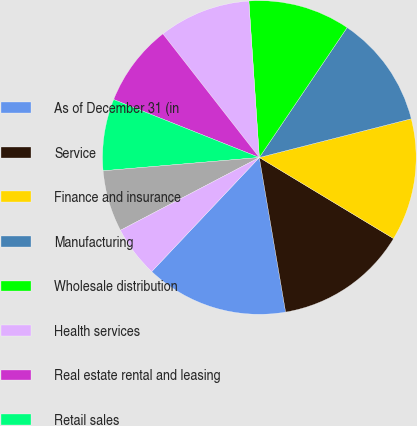Convert chart to OTSL. <chart><loc_0><loc_0><loc_500><loc_500><pie_chart><fcel>As of December 31 (in<fcel>Service<fcel>Finance and insurance<fcel>Manufacturing<fcel>Wholesale distribution<fcel>Health services<fcel>Real estate rental and leasing<fcel>Retail sales<fcel>Transportation/utility<fcel>Construction<nl><fcel>14.72%<fcel>13.67%<fcel>12.62%<fcel>11.57%<fcel>10.52%<fcel>9.48%<fcel>8.43%<fcel>7.38%<fcel>6.33%<fcel>5.28%<nl></chart> 